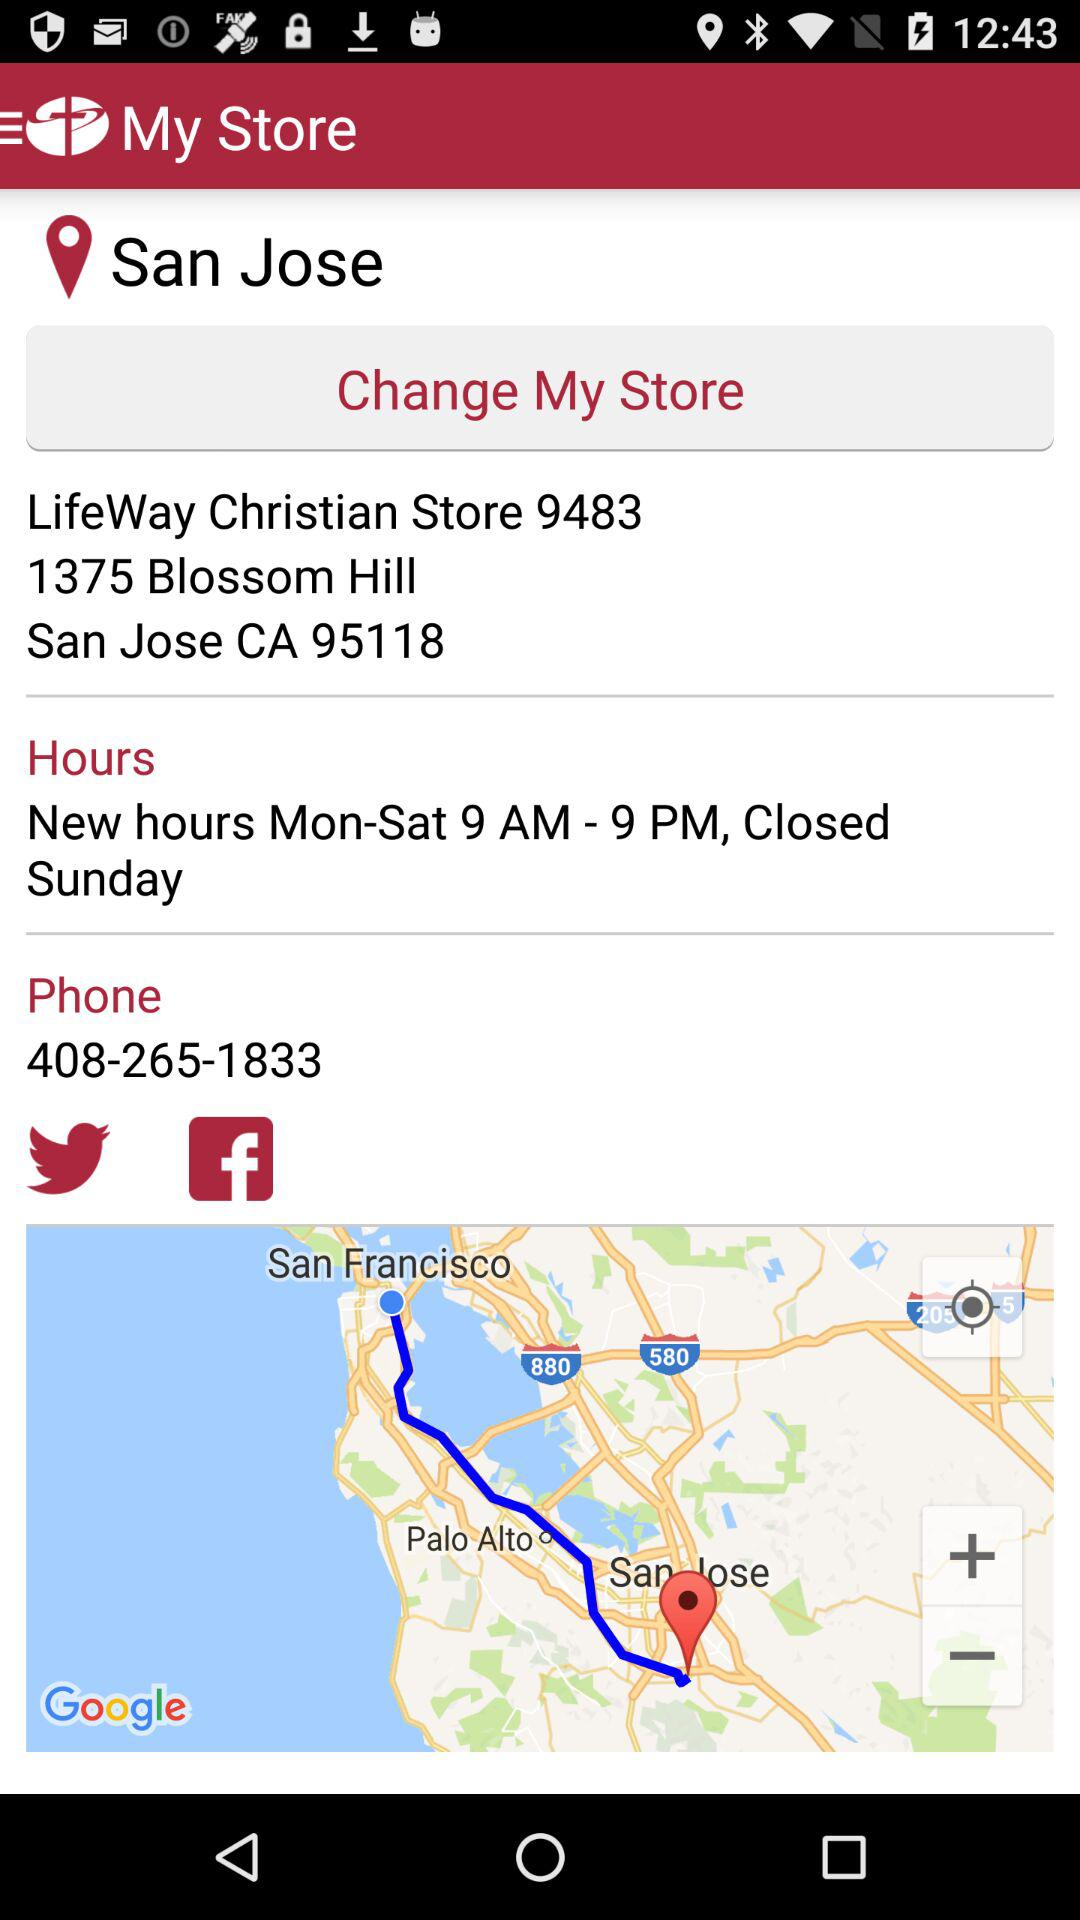What is the phone number shown on the screen? The phone number is 408-265-1833. 